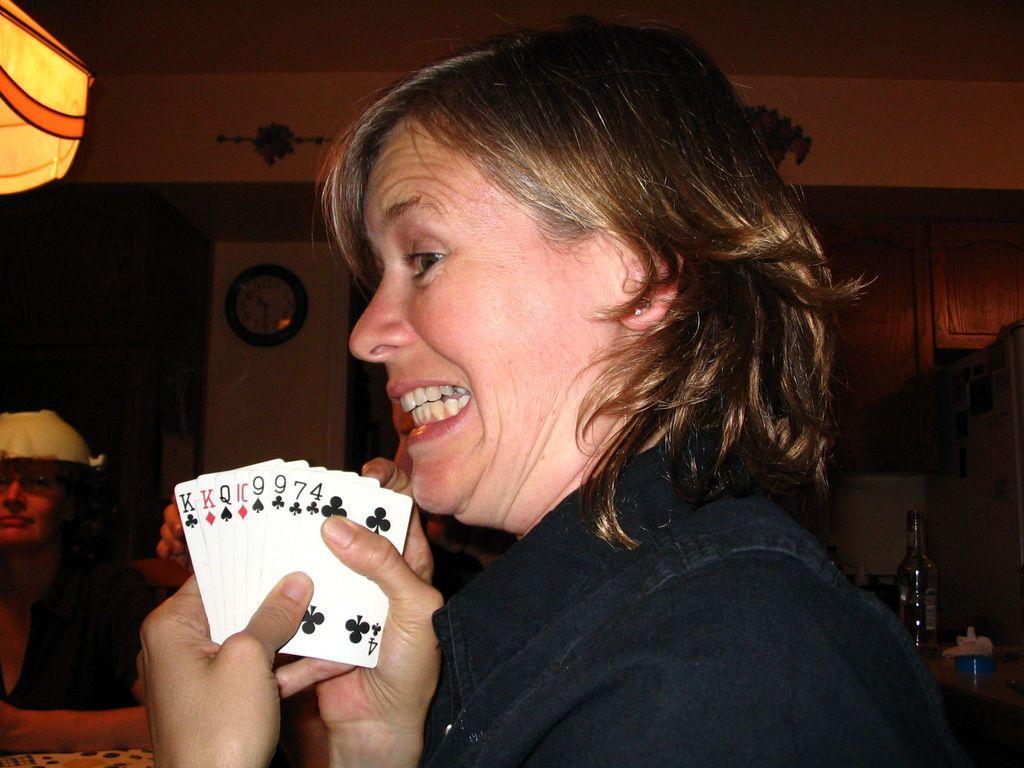Can you describe this image briefly? In this picture there is a woman wearing a black color coat showing the white playing card and giving a pose into the camera. Behind there is a yellow color wall and clock. 